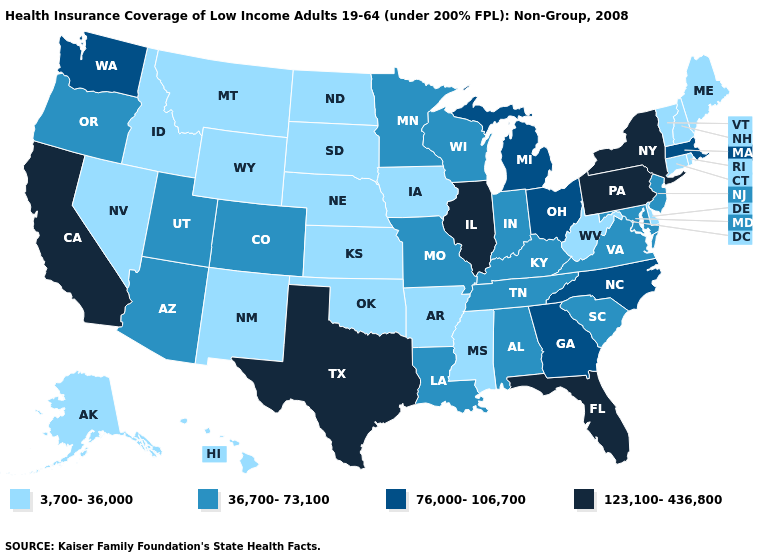What is the value of South Dakota?
Concise answer only. 3,700-36,000. What is the lowest value in the USA?
Keep it brief. 3,700-36,000. Does Rhode Island have the highest value in the Northeast?
Answer briefly. No. Name the states that have a value in the range 36,700-73,100?
Quick response, please. Alabama, Arizona, Colorado, Indiana, Kentucky, Louisiana, Maryland, Minnesota, Missouri, New Jersey, Oregon, South Carolina, Tennessee, Utah, Virginia, Wisconsin. Among the states that border Florida , does Georgia have the highest value?
Be succinct. Yes. What is the value of Michigan?
Keep it brief. 76,000-106,700. Name the states that have a value in the range 76,000-106,700?
Concise answer only. Georgia, Massachusetts, Michigan, North Carolina, Ohio, Washington. Does the map have missing data?
Be succinct. No. What is the value of New Jersey?
Short answer required. 36,700-73,100. Among the states that border Iowa , does South Dakota have the lowest value?
Write a very short answer. Yes. Name the states that have a value in the range 3,700-36,000?
Concise answer only. Alaska, Arkansas, Connecticut, Delaware, Hawaii, Idaho, Iowa, Kansas, Maine, Mississippi, Montana, Nebraska, Nevada, New Hampshire, New Mexico, North Dakota, Oklahoma, Rhode Island, South Dakota, Vermont, West Virginia, Wyoming. Among the states that border Washington , does Oregon have the lowest value?
Keep it brief. No. Does the map have missing data?
Write a very short answer. No. Name the states that have a value in the range 123,100-436,800?
Short answer required. California, Florida, Illinois, New York, Pennsylvania, Texas. Which states have the lowest value in the USA?
Concise answer only. Alaska, Arkansas, Connecticut, Delaware, Hawaii, Idaho, Iowa, Kansas, Maine, Mississippi, Montana, Nebraska, Nevada, New Hampshire, New Mexico, North Dakota, Oklahoma, Rhode Island, South Dakota, Vermont, West Virginia, Wyoming. 